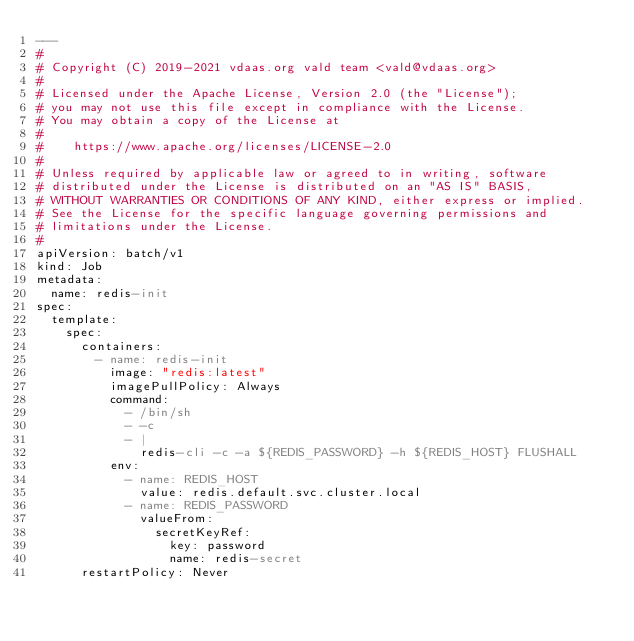Convert code to text. <code><loc_0><loc_0><loc_500><loc_500><_YAML_>---
#
# Copyright (C) 2019-2021 vdaas.org vald team <vald@vdaas.org>
#
# Licensed under the Apache License, Version 2.0 (the "License");
# you may not use this file except in compliance with the License.
# You may obtain a copy of the License at
#
#    https://www.apache.org/licenses/LICENSE-2.0
#
# Unless required by applicable law or agreed to in writing, software
# distributed under the License is distributed on an "AS IS" BASIS,
# WITHOUT WARRANTIES OR CONDITIONS OF ANY KIND, either express or implied.
# See the License for the specific language governing permissions and
# limitations under the License.
#
apiVersion: batch/v1
kind: Job
metadata:
  name: redis-init
spec:
  template:
    spec:
      containers:
        - name: redis-init
          image: "redis:latest"
          imagePullPolicy: Always
          command:
            - /bin/sh
            - -c
            - |
              redis-cli -c -a ${REDIS_PASSWORD} -h ${REDIS_HOST} FLUSHALL
          env:
            - name: REDIS_HOST
              value: redis.default.svc.cluster.local
            - name: REDIS_PASSWORD
              valueFrom:
                secretKeyRef:
                  key: password
                  name: redis-secret
      restartPolicy: Never
</code> 